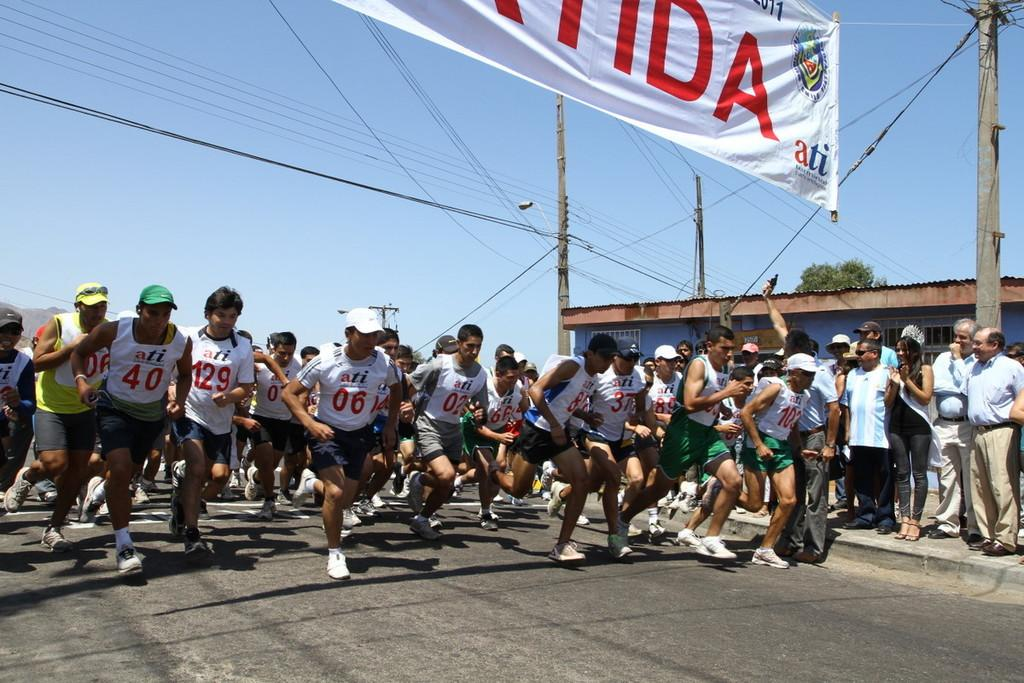What are the men in the image doing? The group of men in the image are running. What event are they participating in? They are participating in a marathon. What can be seen in the background of the image? There is a small house and an electric pole in the background of the image. What is connected to the electric pole? There are cables associated with the electric pole in the background of the image. What is the white object visible in the image? There is a white banner visible in the image. What type of chair is being used by the news reporter in the image? There is no news reporter or chair present in the image. 